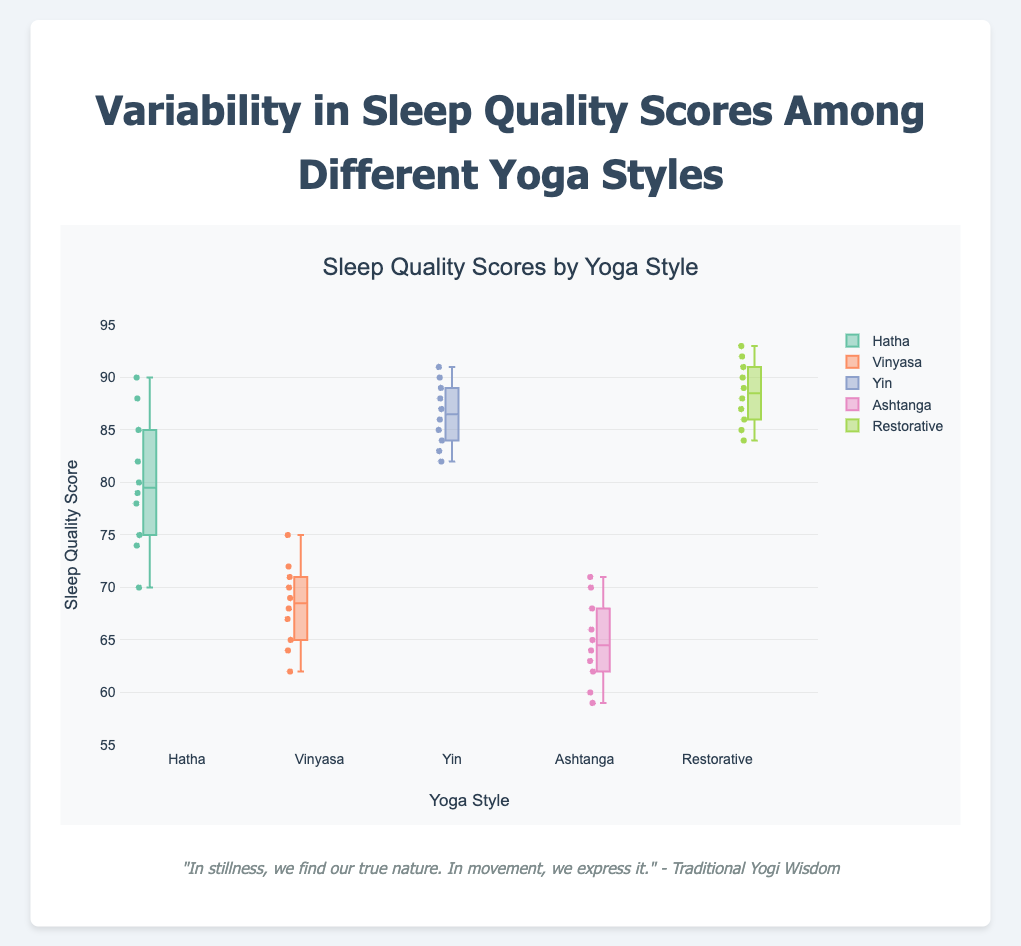What is the title of the plot? The title is located at the top of the plot and summarizes the subject of the figure.
Answer: Variability in Sleep Quality Scores Among Different Yoga Styles What does the y-axis represent in this box plot? The y-axis label, located along the vertical axis, indicates the metric being measured.
Answer: Sleep Quality Score Which yoga style has the highest median sleep quality score? The median is represented by the horizontal line inside each box.
Answer: Restorative How many yoga styles are compared in this plot? Count the number of distinct boxes or labels along the x-axis.
Answer: Five Which yoga style shows the widest range of sleep quality scores? The range can be identified by the length from the lowest to the highest whisker of each box.
Answer: Ashtanga What's the interquartile range (IQR) for Vinyasa yoga style? The IQR is the range between the first quartile (bottom edge of the box) and the third quartile (top edge of the box) of the Vinyasa box.
Answer: Approximately 8 (71 - 63) Which yoga style has the smallest median sleep quality score? Compare the median lines for each group; the smallest is the lowest down the y-axis.
Answer: Ashtanga How does the median sleep quality score for Hatha compare to Yin? Observe the medians of both groups and note the relative position of the lines.
Answer: Yin has a higher median than Hatha What is the maximum sleep quality score recorded for Restorative yoga? The maximum value is represented by the top whisker or the highest point for Restorative yoga.
Answer: 93 How do the sleep quality scores for Hatha and Vinyasa compare in terms of variability? Examine the length of the boxes and whiskers for both categories to assess which has more spread in its data.
Answer: Hatha has less variability than Vinyasa 